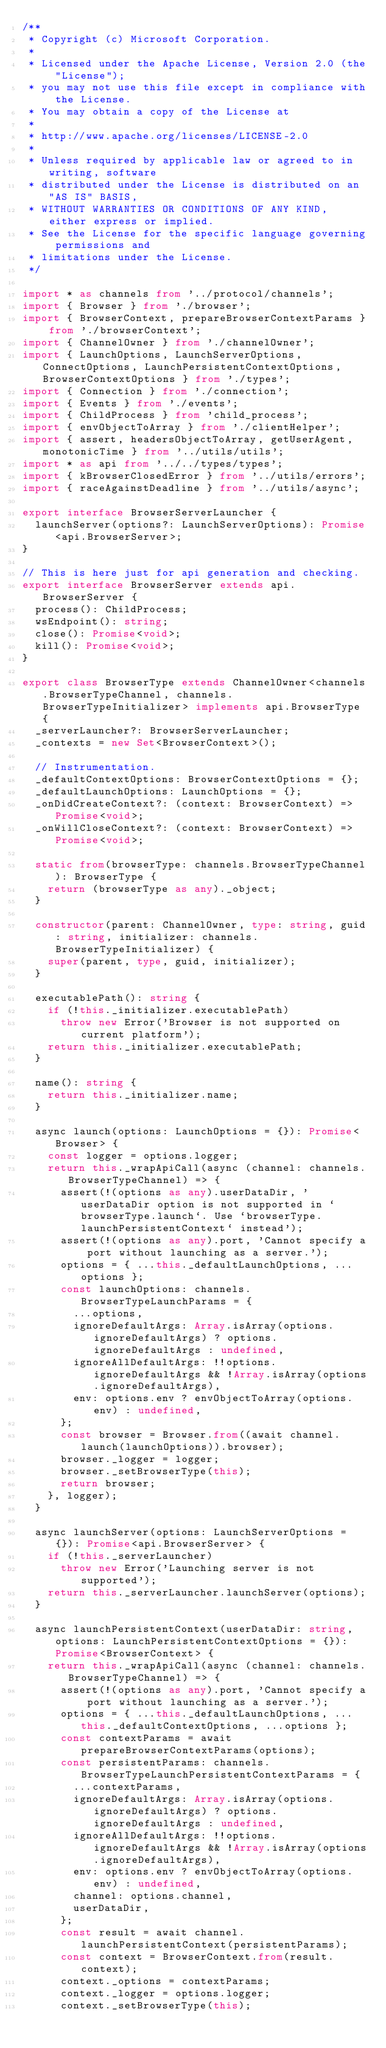Convert code to text. <code><loc_0><loc_0><loc_500><loc_500><_TypeScript_>/**
 * Copyright (c) Microsoft Corporation.
 *
 * Licensed under the Apache License, Version 2.0 (the "License");
 * you may not use this file except in compliance with the License.
 * You may obtain a copy of the License at
 *
 * http://www.apache.org/licenses/LICENSE-2.0
 *
 * Unless required by applicable law or agreed to in writing, software
 * distributed under the License is distributed on an "AS IS" BASIS,
 * WITHOUT WARRANTIES OR CONDITIONS OF ANY KIND, either express or implied.
 * See the License for the specific language governing permissions and
 * limitations under the License.
 */

import * as channels from '../protocol/channels';
import { Browser } from './browser';
import { BrowserContext, prepareBrowserContextParams } from './browserContext';
import { ChannelOwner } from './channelOwner';
import { LaunchOptions, LaunchServerOptions, ConnectOptions, LaunchPersistentContextOptions, BrowserContextOptions } from './types';
import { Connection } from './connection';
import { Events } from './events';
import { ChildProcess } from 'child_process';
import { envObjectToArray } from './clientHelper';
import { assert, headersObjectToArray, getUserAgent, monotonicTime } from '../utils/utils';
import * as api from '../../types/types';
import { kBrowserClosedError } from '../utils/errors';
import { raceAgainstDeadline } from '../utils/async';

export interface BrowserServerLauncher {
  launchServer(options?: LaunchServerOptions): Promise<api.BrowserServer>;
}

// This is here just for api generation and checking.
export interface BrowserServer extends api.BrowserServer {
  process(): ChildProcess;
  wsEndpoint(): string;
  close(): Promise<void>;
  kill(): Promise<void>;
}

export class BrowserType extends ChannelOwner<channels.BrowserTypeChannel, channels.BrowserTypeInitializer> implements api.BrowserType {
  _serverLauncher?: BrowserServerLauncher;
  _contexts = new Set<BrowserContext>();

  // Instrumentation.
  _defaultContextOptions: BrowserContextOptions = {};
  _defaultLaunchOptions: LaunchOptions = {};
  _onDidCreateContext?: (context: BrowserContext) => Promise<void>;
  _onWillCloseContext?: (context: BrowserContext) => Promise<void>;

  static from(browserType: channels.BrowserTypeChannel): BrowserType {
    return (browserType as any)._object;
  }

  constructor(parent: ChannelOwner, type: string, guid: string, initializer: channels.BrowserTypeInitializer) {
    super(parent, type, guid, initializer);
  }

  executablePath(): string {
    if (!this._initializer.executablePath)
      throw new Error('Browser is not supported on current platform');
    return this._initializer.executablePath;
  }

  name(): string {
    return this._initializer.name;
  }

  async launch(options: LaunchOptions = {}): Promise<Browser> {
    const logger = options.logger;
    return this._wrapApiCall(async (channel: channels.BrowserTypeChannel) => {
      assert(!(options as any).userDataDir, 'userDataDir option is not supported in `browserType.launch`. Use `browserType.launchPersistentContext` instead');
      assert(!(options as any).port, 'Cannot specify a port without launching as a server.');
      options = { ...this._defaultLaunchOptions, ...options };
      const launchOptions: channels.BrowserTypeLaunchParams = {
        ...options,
        ignoreDefaultArgs: Array.isArray(options.ignoreDefaultArgs) ? options.ignoreDefaultArgs : undefined,
        ignoreAllDefaultArgs: !!options.ignoreDefaultArgs && !Array.isArray(options.ignoreDefaultArgs),
        env: options.env ? envObjectToArray(options.env) : undefined,
      };
      const browser = Browser.from((await channel.launch(launchOptions)).browser);
      browser._logger = logger;
      browser._setBrowserType(this);
      return browser;
    }, logger);
  }

  async launchServer(options: LaunchServerOptions = {}): Promise<api.BrowserServer> {
    if (!this._serverLauncher)
      throw new Error('Launching server is not supported');
    return this._serverLauncher.launchServer(options);
  }

  async launchPersistentContext(userDataDir: string, options: LaunchPersistentContextOptions = {}): Promise<BrowserContext> {
    return this._wrapApiCall(async (channel: channels.BrowserTypeChannel) => {
      assert(!(options as any).port, 'Cannot specify a port without launching as a server.');
      options = { ...this._defaultLaunchOptions, ...this._defaultContextOptions, ...options };
      const contextParams = await prepareBrowserContextParams(options);
      const persistentParams: channels.BrowserTypeLaunchPersistentContextParams = {
        ...contextParams,
        ignoreDefaultArgs: Array.isArray(options.ignoreDefaultArgs) ? options.ignoreDefaultArgs : undefined,
        ignoreAllDefaultArgs: !!options.ignoreDefaultArgs && !Array.isArray(options.ignoreDefaultArgs),
        env: options.env ? envObjectToArray(options.env) : undefined,
        channel: options.channel,
        userDataDir,
      };
      const result = await channel.launchPersistentContext(persistentParams);
      const context = BrowserContext.from(result.context);
      context._options = contextParams;
      context._logger = options.logger;
      context._setBrowserType(this);</code> 